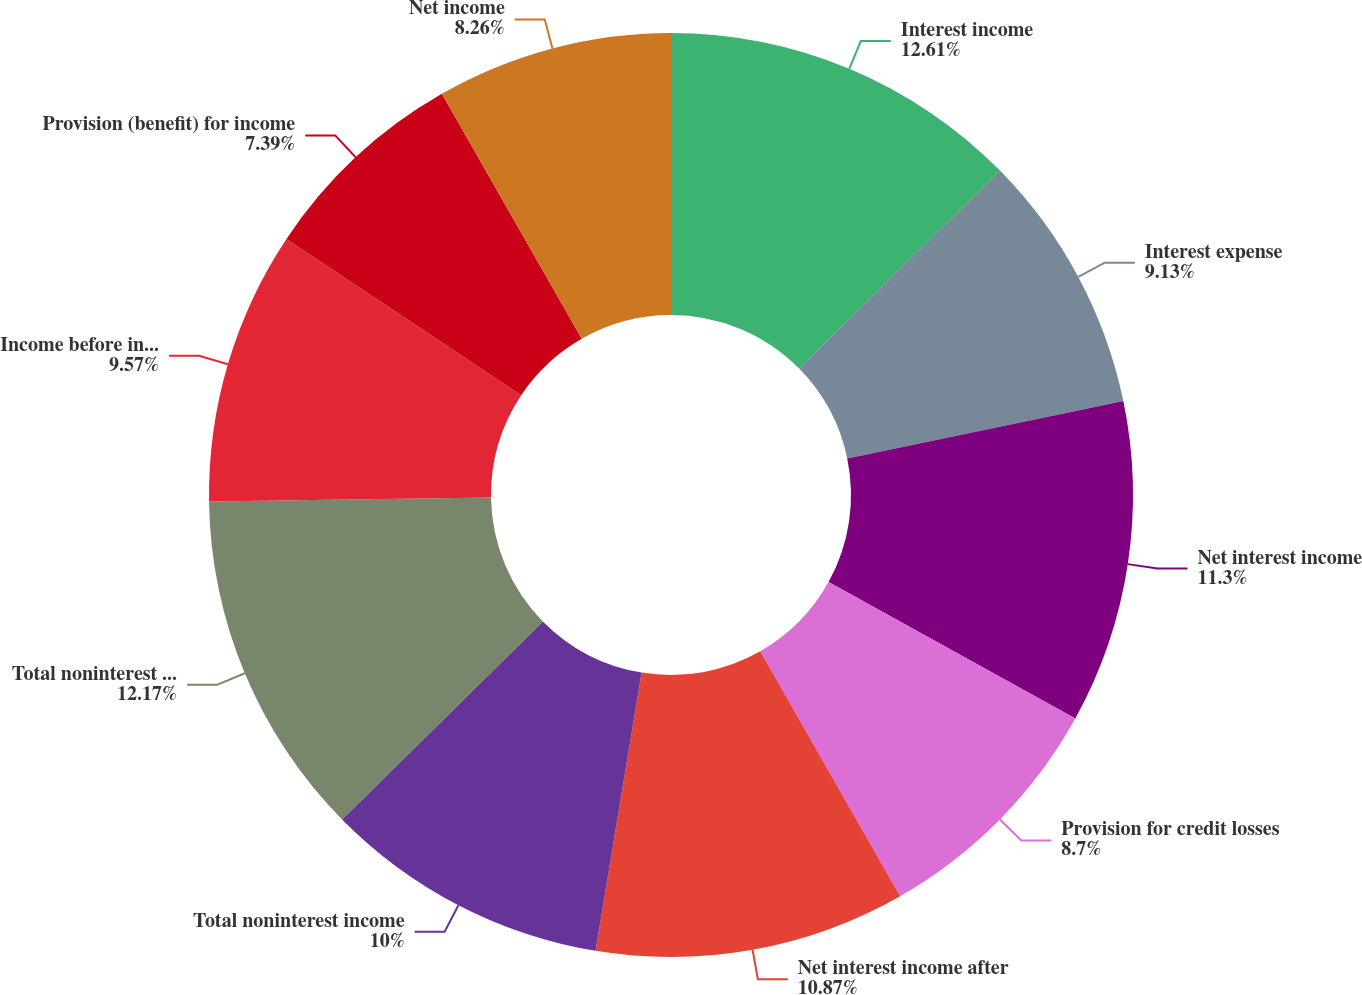Convert chart. <chart><loc_0><loc_0><loc_500><loc_500><pie_chart><fcel>Interest income<fcel>Interest expense<fcel>Net interest income<fcel>Provision for credit losses<fcel>Net interest income after<fcel>Total noninterest income<fcel>Total noninterest expense<fcel>Income before income taxes<fcel>Provision (benefit) for income<fcel>Net income<nl><fcel>12.61%<fcel>9.13%<fcel>11.3%<fcel>8.7%<fcel>10.87%<fcel>10.0%<fcel>12.17%<fcel>9.57%<fcel>7.39%<fcel>8.26%<nl></chart> 